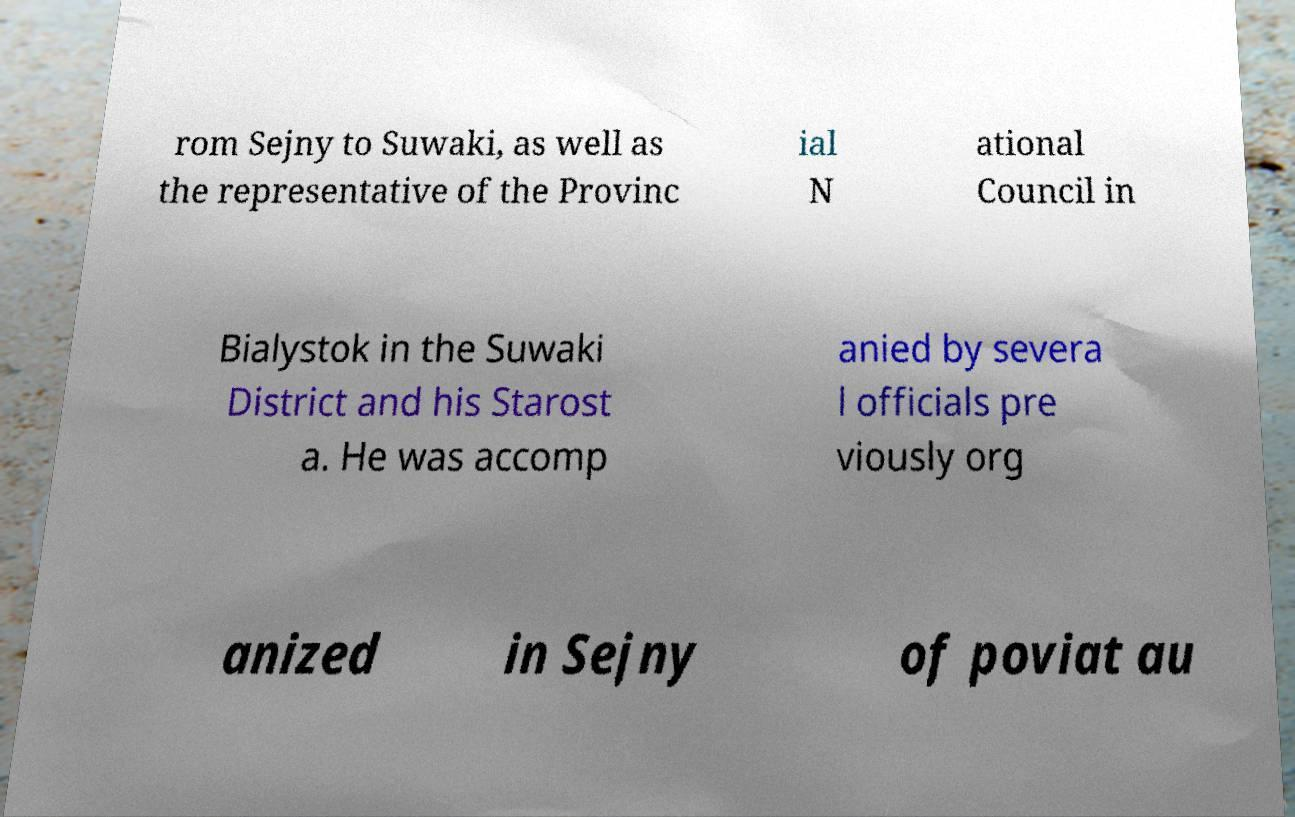Please read and relay the text visible in this image. What does it say? rom Sejny to Suwaki, as well as the representative of the Provinc ial N ational Council in Bialystok in the Suwaki District and his Starost a. He was accomp anied by severa l officials pre viously org anized in Sejny of poviat au 